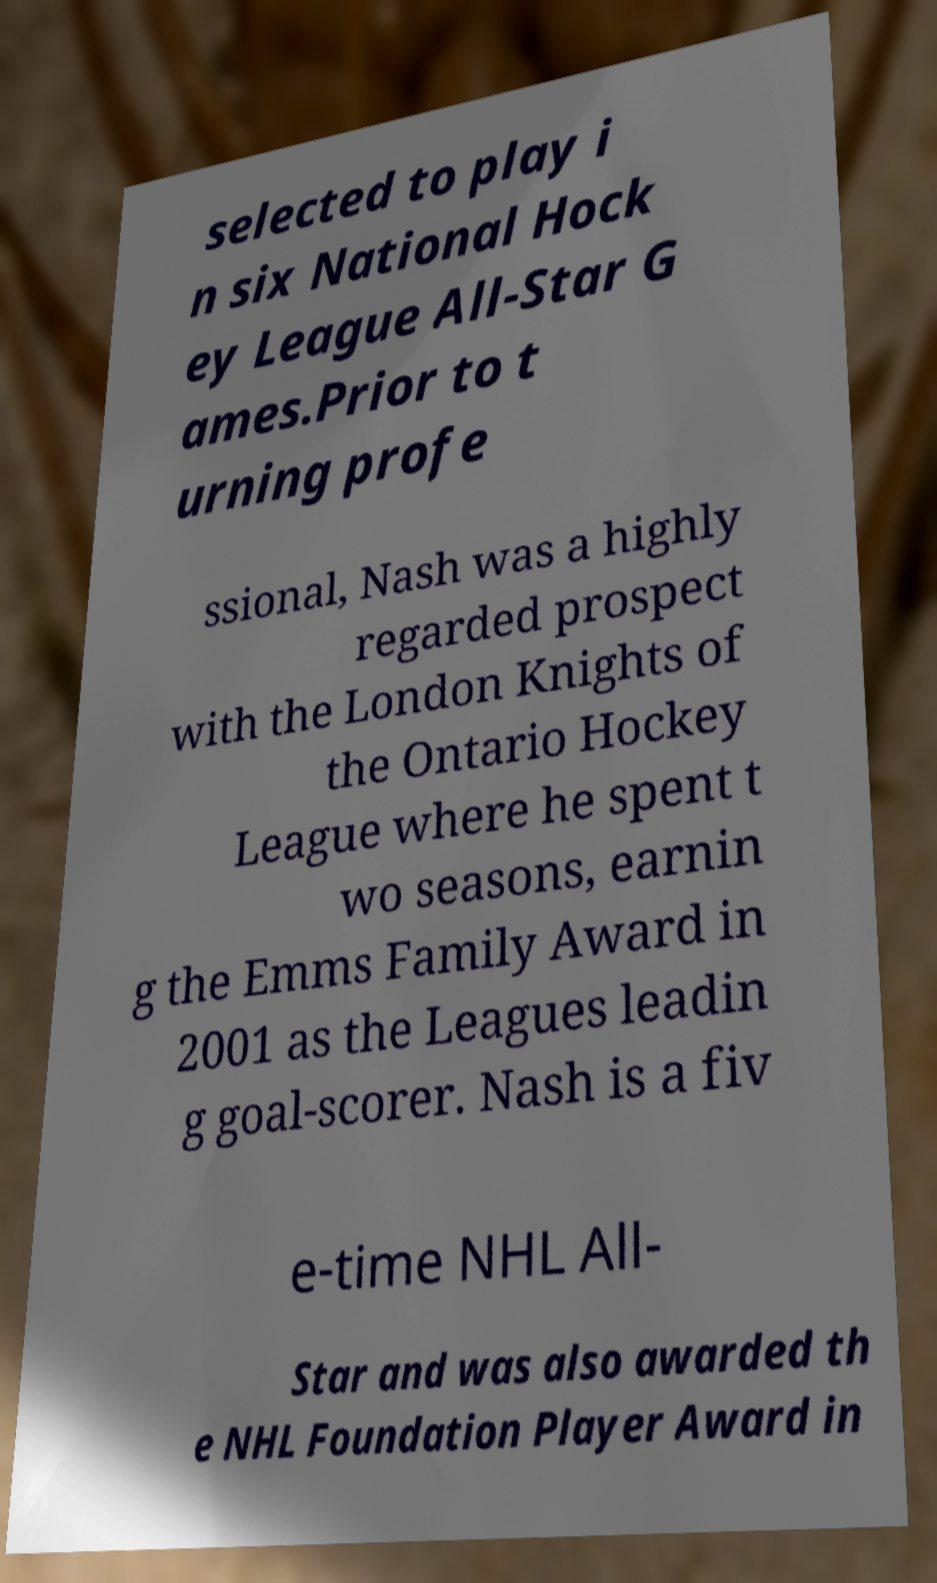Could you extract and type out the text from this image? selected to play i n six National Hock ey League All-Star G ames.Prior to t urning profe ssional, Nash was a highly regarded prospect with the London Knights of the Ontario Hockey League where he spent t wo seasons, earnin g the Emms Family Award in 2001 as the Leagues leadin g goal-scorer. Nash is a fiv e-time NHL All- Star and was also awarded th e NHL Foundation Player Award in 